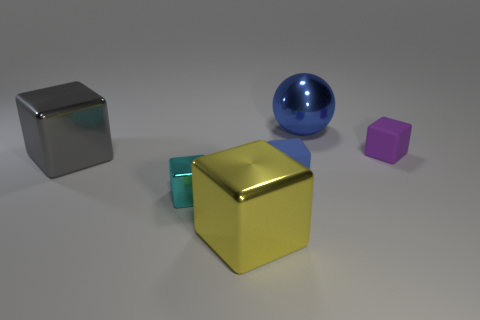Is the cyan block made of the same material as the large blue ball?
Give a very brief answer. Yes. There is a block that is the same size as the gray thing; what color is it?
Give a very brief answer. Yellow. What color is the cube that is both behind the blue matte object and on the left side of the purple cube?
Ensure brevity in your answer.  Gray. There is a small object that is the same color as the shiny ball; what is its shape?
Provide a succinct answer. Cube. How big is the metallic object on the right side of the metallic block in front of the small object that is to the left of the yellow metallic block?
Provide a succinct answer. Large. What is the tiny blue object made of?
Your answer should be very brief. Rubber. Are the large gray block and the object that is right of the big blue thing made of the same material?
Provide a short and direct response. No. Is there anything else that is the same color as the shiny ball?
Offer a very short reply. Yes. There is a matte block behind the blue thing in front of the small purple matte cube; is there a large object behind it?
Make the answer very short. Yes. The big shiny sphere has what color?
Offer a very short reply. Blue. 